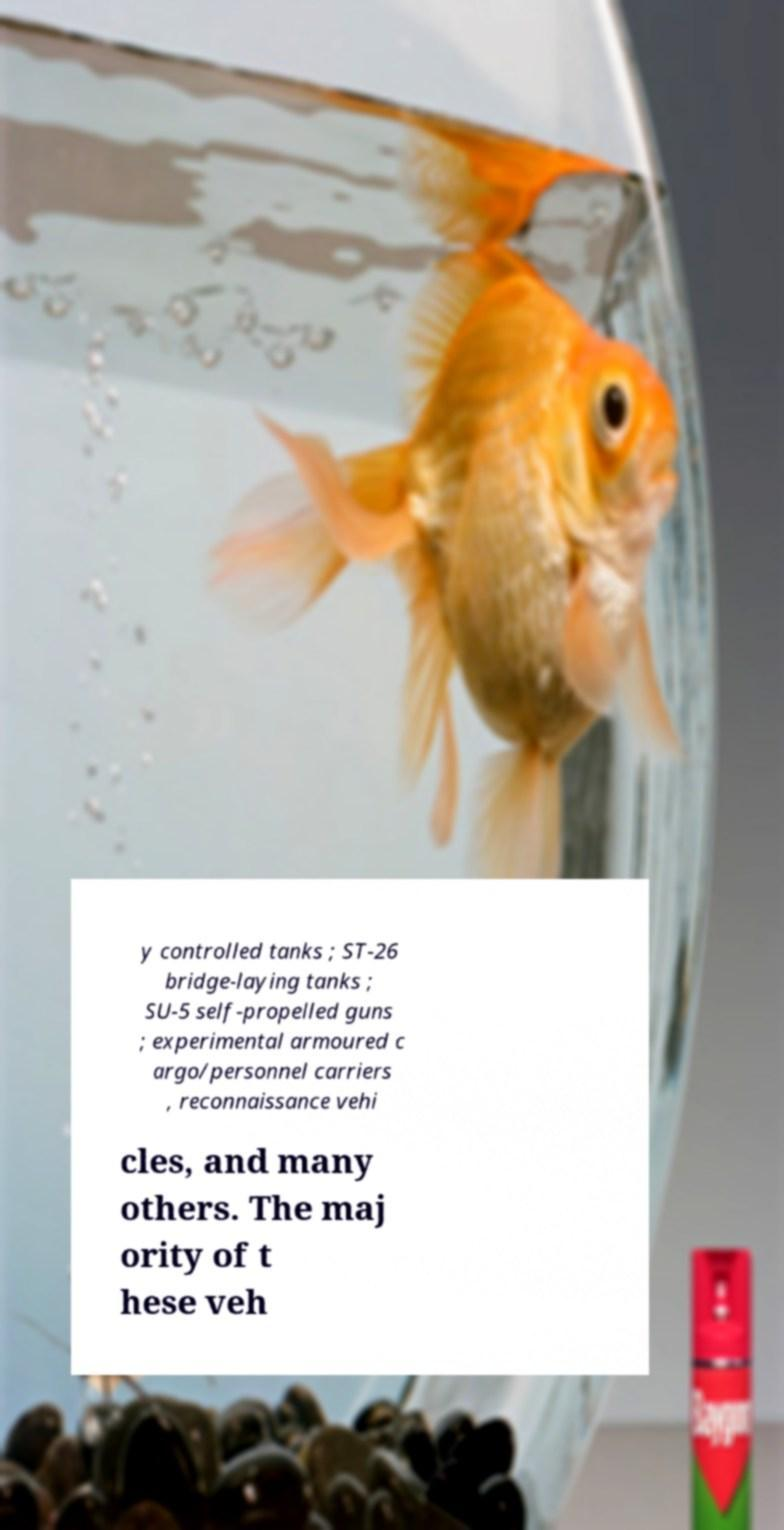Can you accurately transcribe the text from the provided image for me? y controlled tanks ; ST-26 bridge-laying tanks ; SU-5 self-propelled guns ; experimental armoured c argo/personnel carriers , reconnaissance vehi cles, and many others. The maj ority of t hese veh 